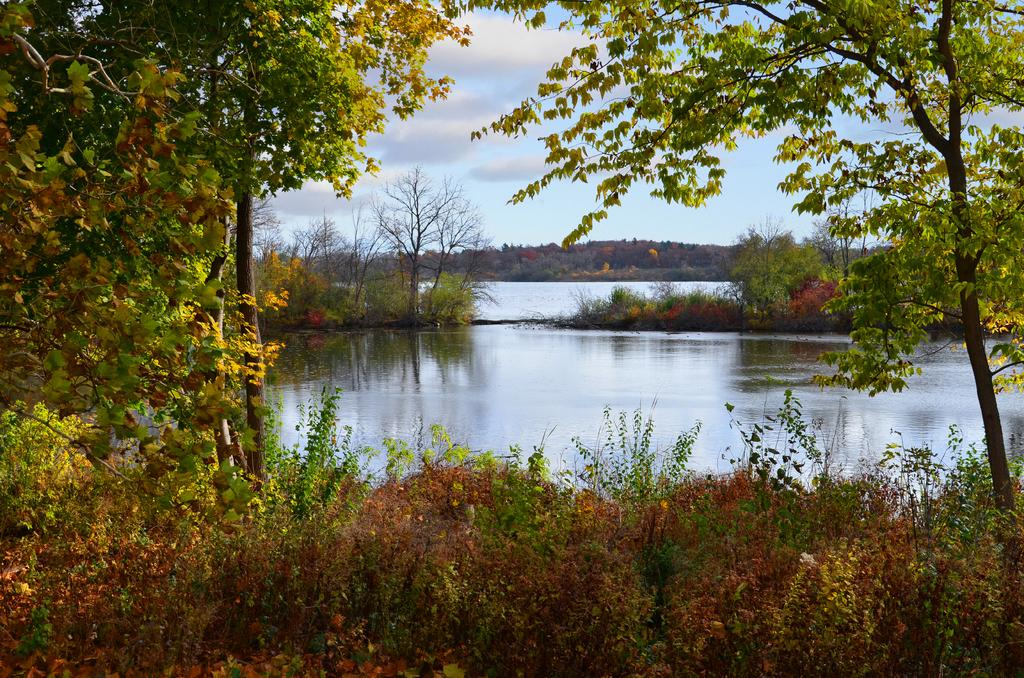What type of natural environment is depicted in the image? The image features many trees and plants, indicating a forest or woodland setting. What body of water is visible in the image? There is a sea in the image. What type of landform can be seen in the image? There are hills in the image. How would you describe the sky in the image? The sky is blue and cloudy in the image. What type of grain is being harvested in the wilderness in the image? There is no grain or wilderness present in the image; it features a forest or woodland setting with a sea and hills. 